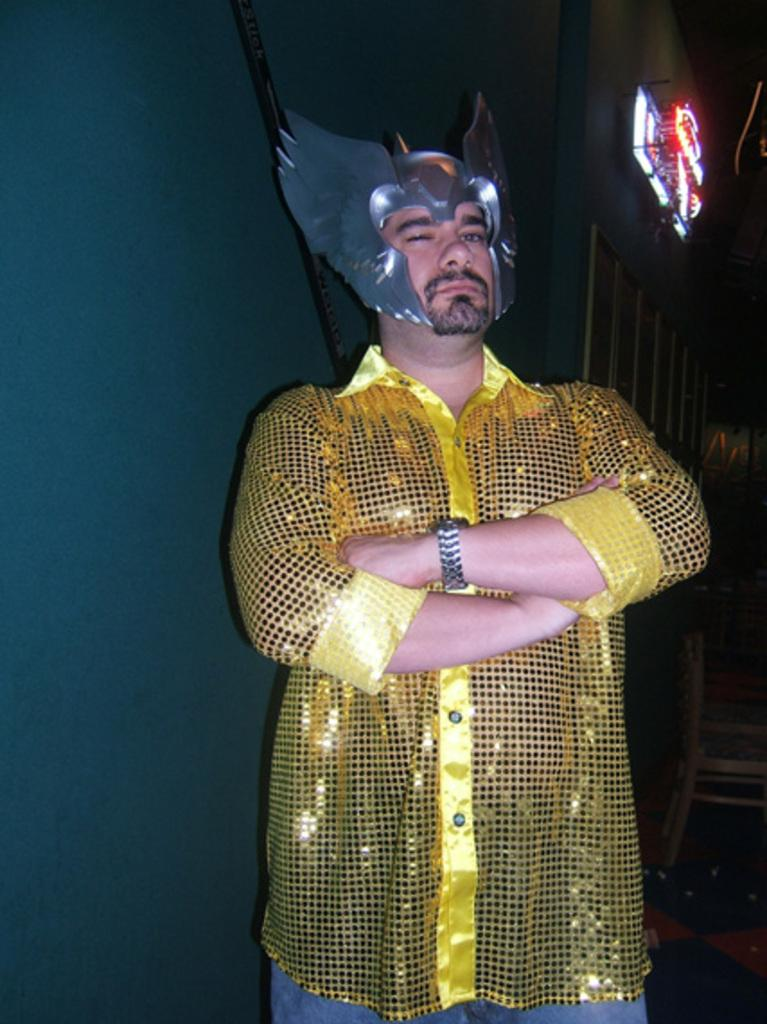What is the person in the image wearing on their face? The person in the image is wearing a mask. What can be seen on the left side of the image? There is a wall on the left side of the image. What is located at the top right corner of the image? There is a board with lighting at the top right corner of the image. What type of pain is the person in the image experiencing? There is no indication in the image that the person is experiencing any pain. 